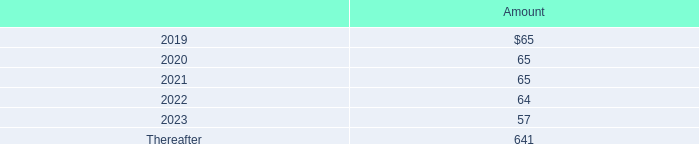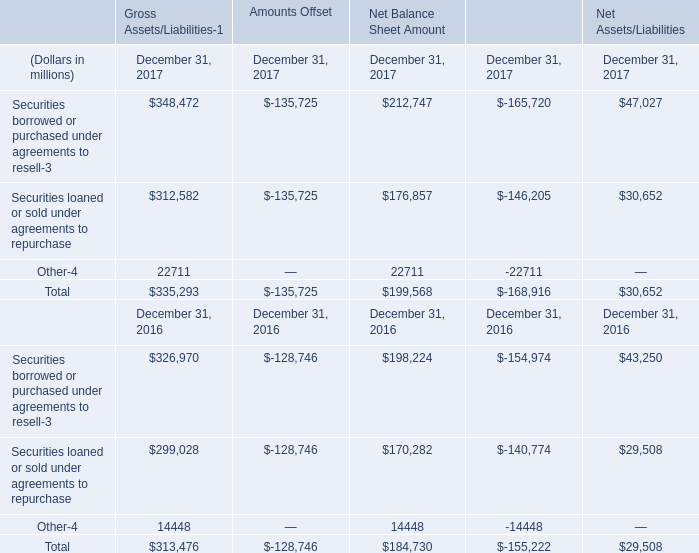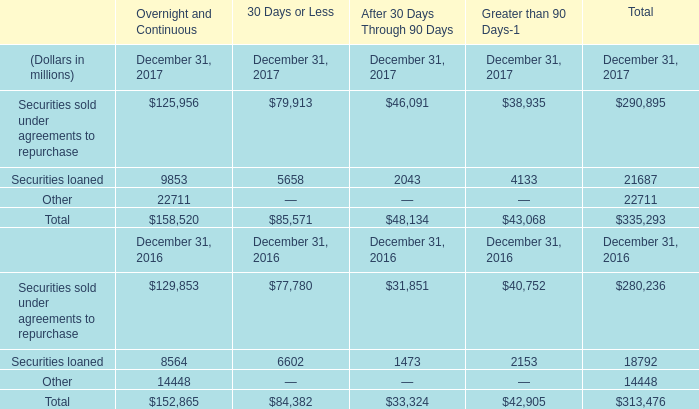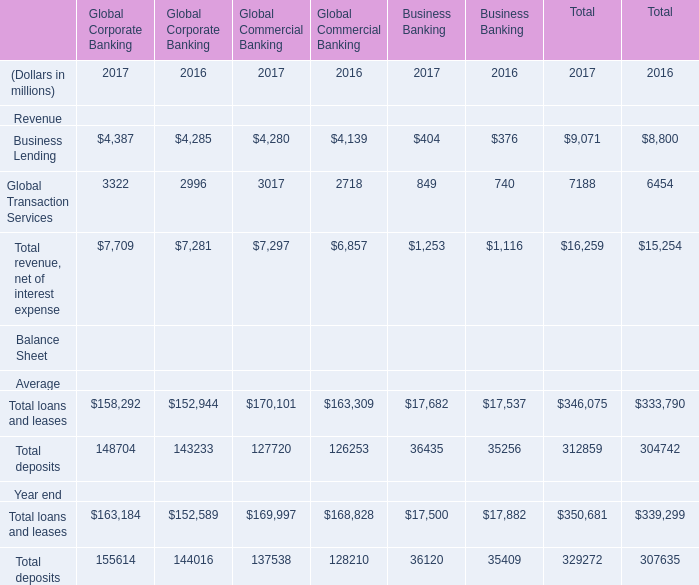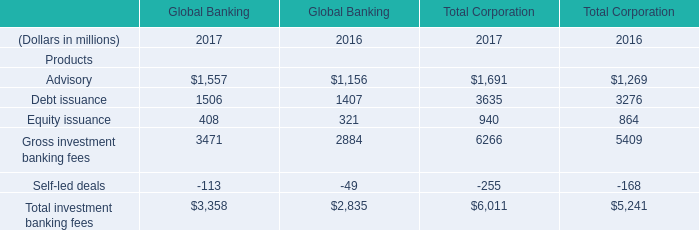What is the total amount of Other of Financial Instruments December 31, 2017, Global Transaction Services of Global Commercial Banking 2017, and Total loans and leases Year end of Total 2016 ? 
Computations: ((22711.0 + 3017.0) + 339299.0)
Answer: 365027.0. 